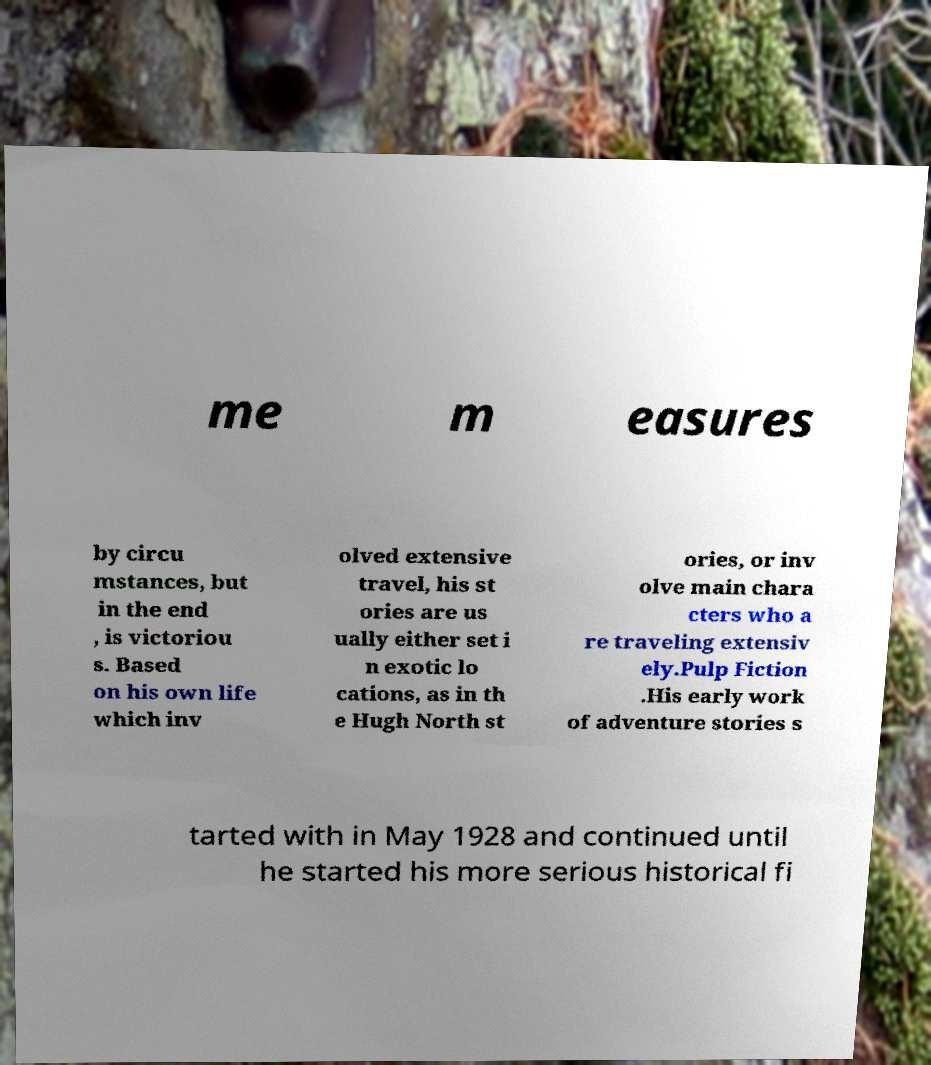Please identify and transcribe the text found in this image. me m easures by circu mstances, but in the end , is victoriou s. Based on his own life which inv olved extensive travel, his st ories are us ually either set i n exotic lo cations, as in th e Hugh North st ories, or inv olve main chara cters who a re traveling extensiv ely.Pulp Fiction .His early work of adventure stories s tarted with in May 1928 and continued until he started his more serious historical fi 